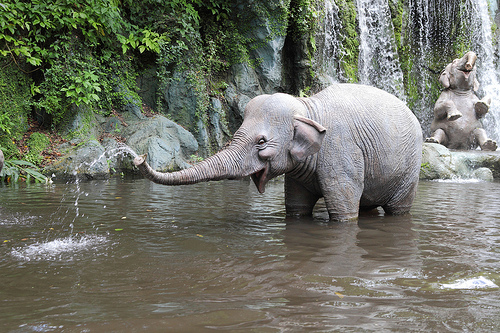What activity is the elephant engaging in at the moment? The elephant is playfully splashing water with its trunk. This behavior is typical for elephants when they're bathing or cooling off, as well as for social interaction and play among herd members. 